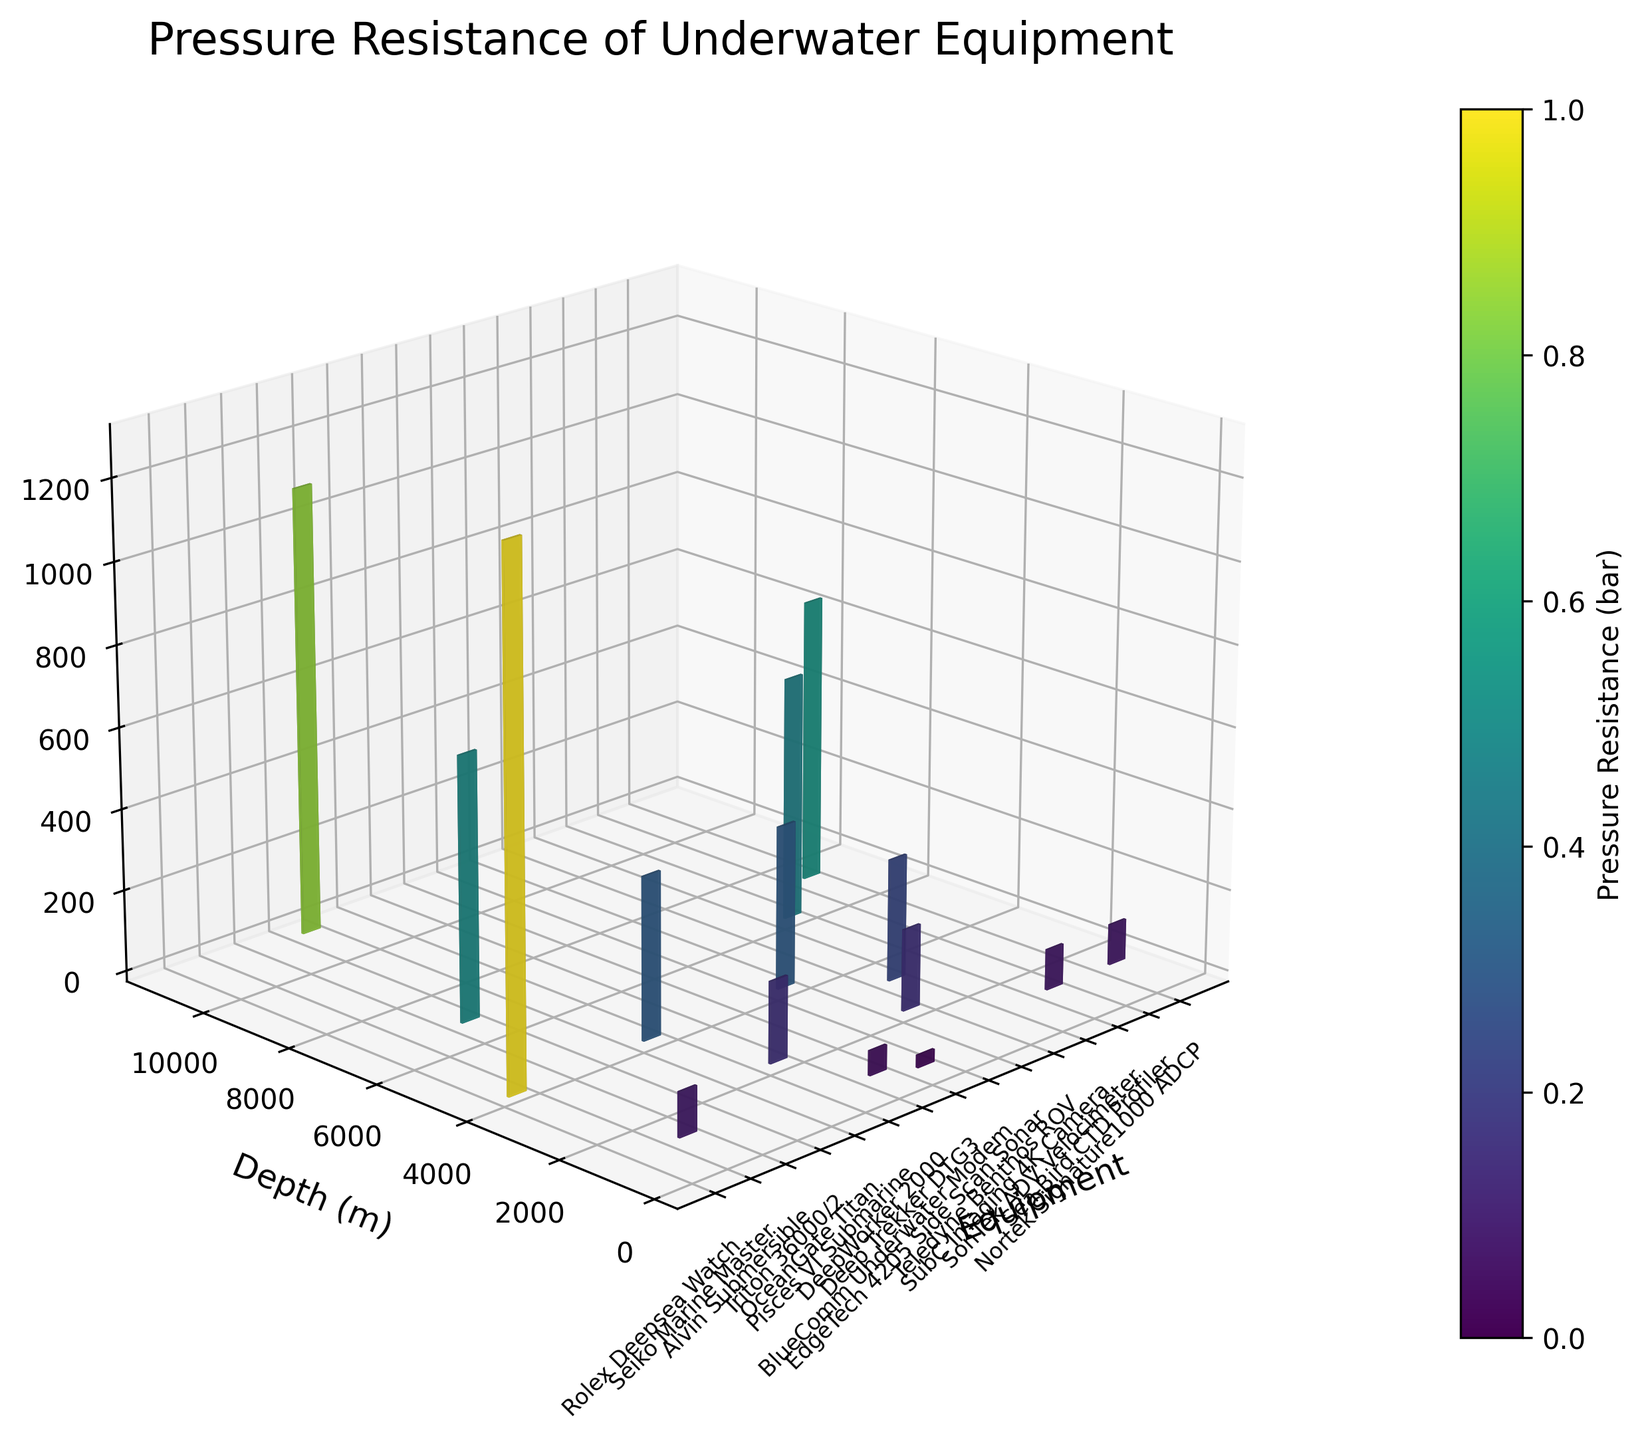Which equipment has the highest pressure resistance? By looking at the height of the bars, identify the equipment with the highest bar. The 'Triton 36000/2' has the highest bar indicating the highest pressure resistance.
Answer: Triton 36000/2 Which equipment is tested at the deepest depth? Check the depth axis (y-axis) and find the maximum value. The 'Triton 36000/2' is tested at 11000 meters, the deepest.
Answer: Triton 36000/2 What is the pressure resistance of the OceanGate Titan? Find the bar representing 'OceanGate Titan' and note its height on the pressure resistance axis (z-axis). The height corresponds to 400 bars.
Answer: 400 bars Are there any pieces of equipment that have the same pressure resistance rating? Compare the heights of all the bars to see if any are equal. 'OceanGate Titan’ and 'BlueComm Underwater Modem' both have a pressure resistance rating of 400 bars.
Answer: Yes, OceanGate Titan and BlueComm Underwater Modem What is the sum of the pressure resistance ratings for Seiko Marine Master and SonTek ADV Velocimeter? Find the heights of the bars for 'Seiko Marine Master' (110 bars) and 'SonTek ADV Velocimeter' (100 bars) and sum them: 110 + 100 = 210.
Answer: 210 bars What is the difference in pressure resistance between the Alvin Submersible and SubC Imaging 4K Camera? Note the heights of the bars for 'Alvin Submersible' (650 bars) and 'SubC Imaging 4K Camera' (600 bars) and subtract them: 650 - 600 = 50.
Answer: 50 bars How many pieces of equipment are rated for depths greater than 2000 meters? Count the number of bars whose depth values on the y-axis are greater than 2000 meters. There are 5 such pieces of equipment.
Answer: 5 Which equipment has a higher pressure resistance: Teledyne Benthos ROV or Sea-Bird CTD Profiler? Compare the heights of the bars for 'Teledyne Benthos ROV' (300 bars) and 'Sea-Bird CTD Profiler' (700 bars). 'Sea-Bird CTD Profiler' has a higher bar indicating higher pressure resistance.
Answer: Sea-Bird CTD Profiler What's the average pressure resistance of the equipment rated for 1000 meters depth? Find the bars with a depth of 1000 meters: 'Seiko Marine Master' (110 bars), 'SonTek ADV Velocimeter' (100 bars), 'Nortek Signature1000 ADCP' (100 bars). Calculate the average: (110 + 100 + 100) / 3 = 103.33.
Answer: 103.33 bars 